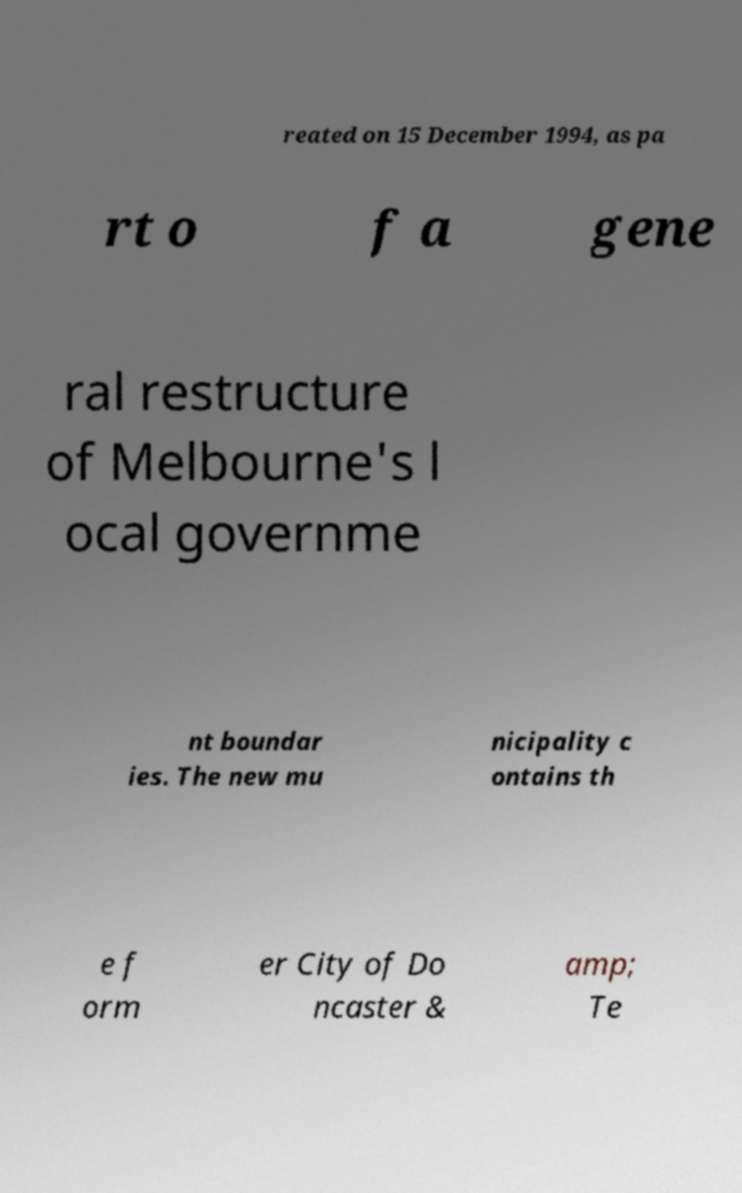Please identify and transcribe the text found in this image. reated on 15 December 1994, as pa rt o f a gene ral restructure of Melbourne's l ocal governme nt boundar ies. The new mu nicipality c ontains th e f orm er City of Do ncaster & amp; Te 